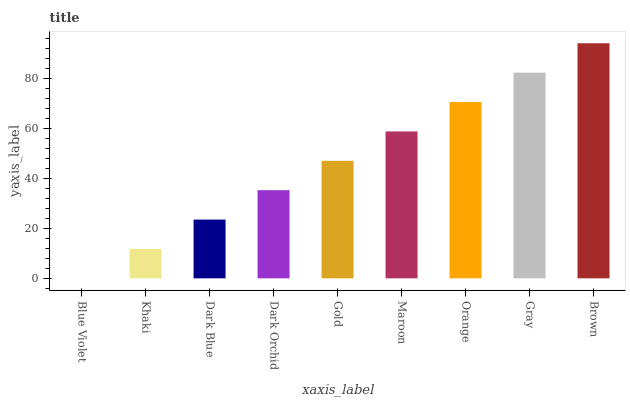Is Blue Violet the minimum?
Answer yes or no. Yes. Is Brown the maximum?
Answer yes or no. Yes. Is Khaki the minimum?
Answer yes or no. No. Is Khaki the maximum?
Answer yes or no. No. Is Khaki greater than Blue Violet?
Answer yes or no. Yes. Is Blue Violet less than Khaki?
Answer yes or no. Yes. Is Blue Violet greater than Khaki?
Answer yes or no. No. Is Khaki less than Blue Violet?
Answer yes or no. No. Is Gold the high median?
Answer yes or no. Yes. Is Gold the low median?
Answer yes or no. Yes. Is Dark Blue the high median?
Answer yes or no. No. Is Dark Orchid the low median?
Answer yes or no. No. 